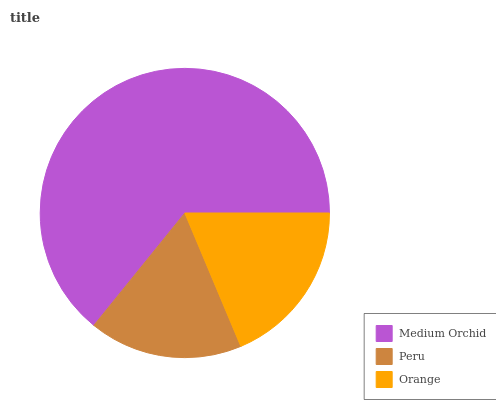Is Peru the minimum?
Answer yes or no. Yes. Is Medium Orchid the maximum?
Answer yes or no. Yes. Is Orange the minimum?
Answer yes or no. No. Is Orange the maximum?
Answer yes or no. No. Is Orange greater than Peru?
Answer yes or no. Yes. Is Peru less than Orange?
Answer yes or no. Yes. Is Peru greater than Orange?
Answer yes or no. No. Is Orange less than Peru?
Answer yes or no. No. Is Orange the high median?
Answer yes or no. Yes. Is Orange the low median?
Answer yes or no. Yes. Is Peru the high median?
Answer yes or no. No. Is Medium Orchid the low median?
Answer yes or no. No. 